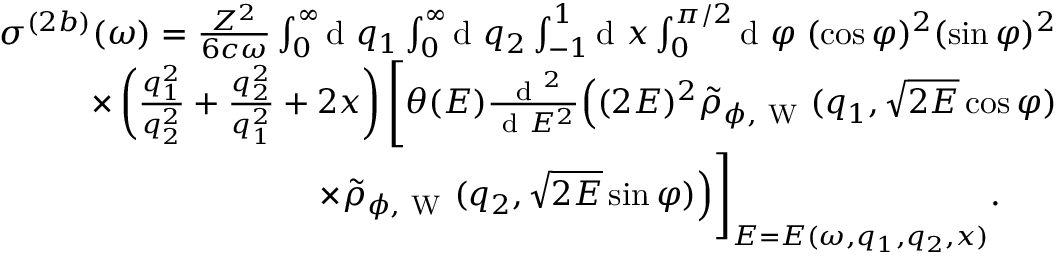<formula> <loc_0><loc_0><loc_500><loc_500>\begin{array} { r } { \sigma ^ { ( 2 b ) } ( \omega ) = \frac { Z ^ { 2 } } { 6 c \omega } \int _ { 0 } ^ { \infty } \, { d } q _ { 1 } \int _ { 0 } ^ { \infty } \, { d } q _ { 2 } \int _ { - 1 } ^ { 1 } \, { d } x \int _ { 0 } ^ { \pi / 2 } \, { d } \varphi \, ( \cos \varphi ) ^ { 2 } ( \sin \varphi ) ^ { 2 } } \\ { \times \left ( \frac { q _ { 1 } ^ { 2 } } { q _ { 2 } ^ { 2 } } + \frac { q _ { 2 } ^ { 2 } } { q _ { 1 } ^ { 2 } } + 2 x \right ) \left [ \theta ( E ) \frac { { d } ^ { 2 } } { { d } E ^ { 2 } } \left ( ( 2 E ) ^ { 2 } \tilde { \rho } _ { \phi , W } ( q _ { 1 } , \sqrt { 2 E } \cos \varphi ) } \\ { \times \tilde { \rho } _ { \phi , W } ( q _ { 2 } , \sqrt { 2 E } \sin \varphi ) \right ) \right ] _ { E = E ( \omega , q _ { 1 } , q _ { 2 } , x ) } . \, } \end{array}</formula> 